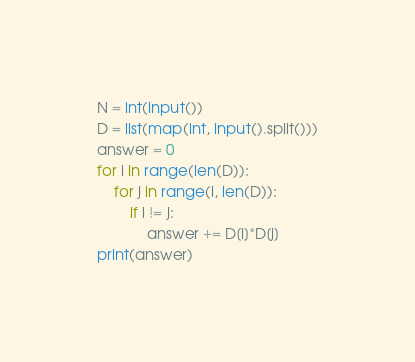Convert code to text. <code><loc_0><loc_0><loc_500><loc_500><_Python_>N = int(input())
D = list(map(int, input().split()))
answer = 0
for i in range(len(D)):
    for j in range(i, len(D)):
        if i != j:
            answer += D[i]*D[j]
print(answer)</code> 